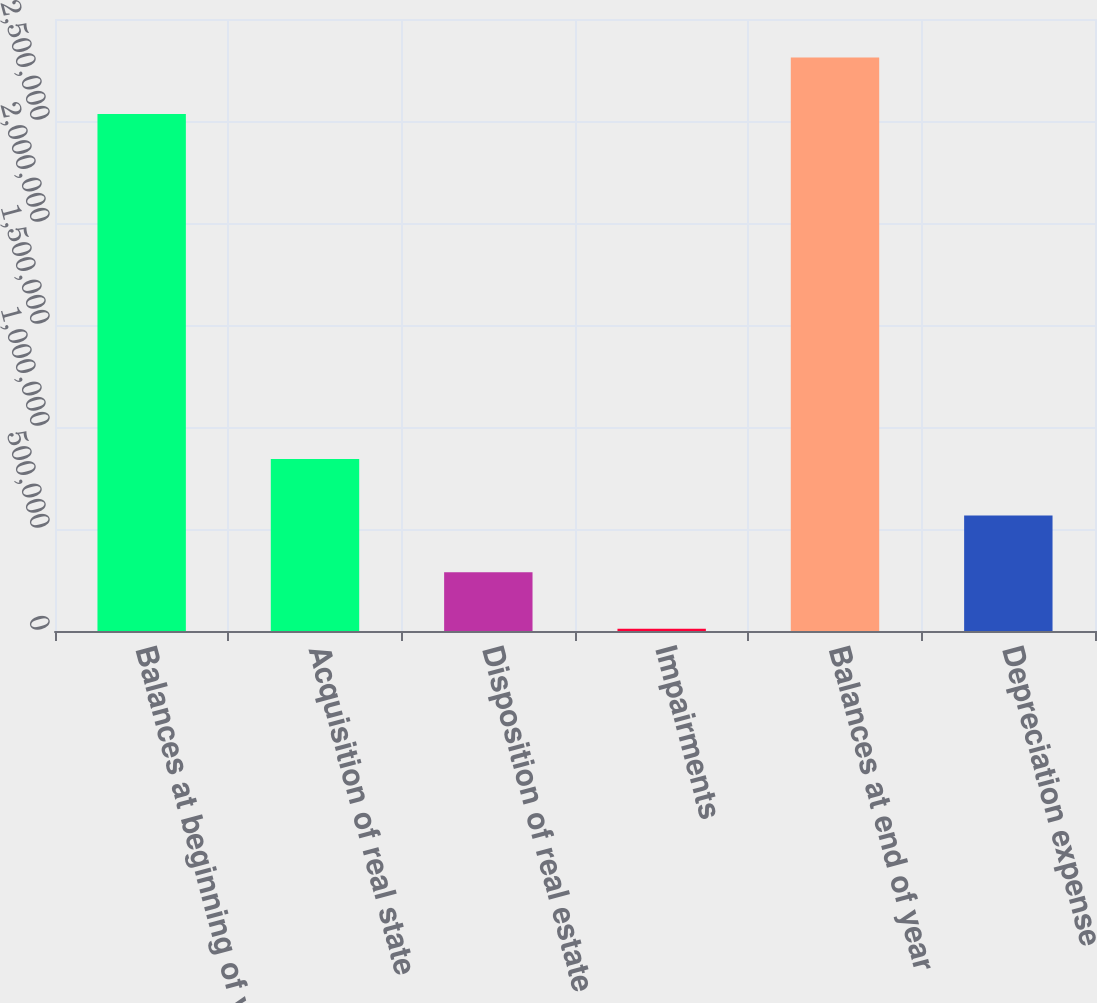<chart> <loc_0><loc_0><loc_500><loc_500><bar_chart><fcel>Balances at beginning of year<fcel>Acquisition of real state<fcel>Disposition of real estate<fcel>Impairments<fcel>Balances at end of year<fcel>Depreciation expense<nl><fcel>2.53453e+06<fcel>842845<fcel>288286<fcel>11007<fcel>2.81181e+06<fcel>565565<nl></chart> 